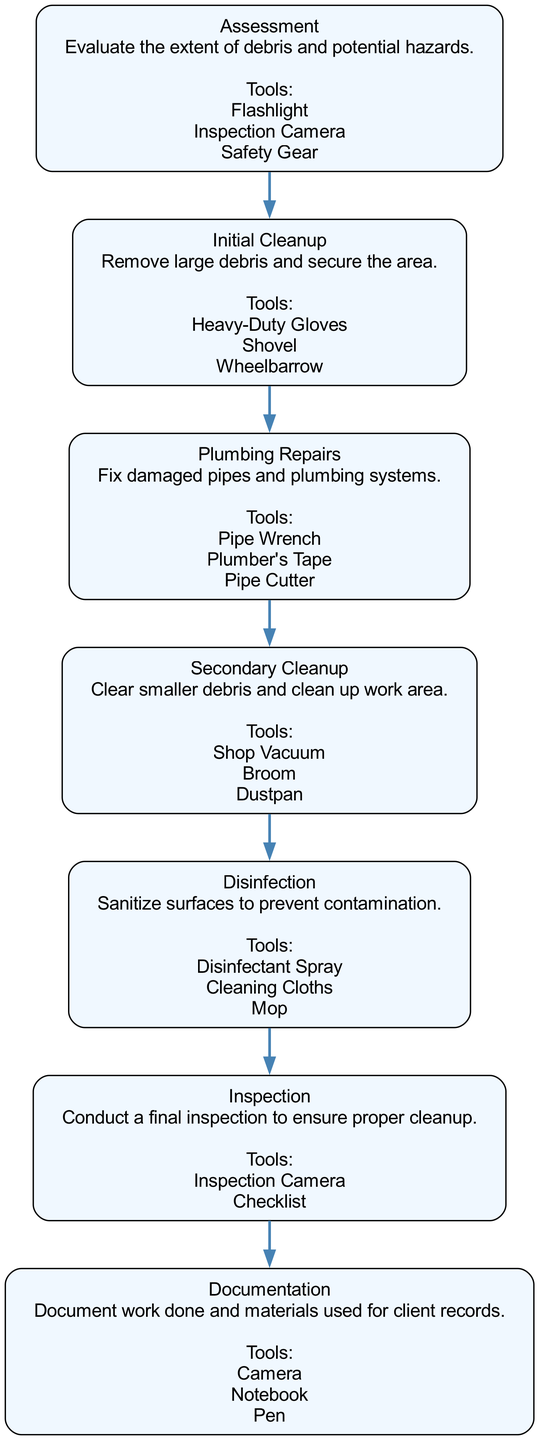What is the first step in the debris removal process? The diagram starts with the "Assessment" step, which is the initial stage of the process to evaluate the extent of debris and potential hazards.
Answer: Assessment How many tools are listed for the "Plumbing Repairs" step? In the "Plumbing Repairs" step, there are three tools mentioned: Pipe Wrench, Plumber's Tape, and Pipe Cutter.
Answer: 3 What step follows "Initial Cleanup"? The diagram shows that the step after "Initial Cleanup" is "Plumbing Repairs," indicating the progression from clearing larger debris to addressing plumbing issues.
Answer: Plumbing Repairs Which tool is used for the "Disinfection" step? The "Disinfection" step lists Disinfectant Spray, Cleaning Cloths, and Mop as tools, making them essential for sanitizing surfaces.
Answer: Disinfectant Spray What is the last step in the Clinical Pathway? The final step in the diagram is "Documentation," which denotes the importance of recording all work done and materials used for client records.
Answer: Documentation How is the "Secondary Cleanup" related to the previous step? "Secondary Cleanup" directly follows "Plumbing Repairs," showing that after plumbing issues are fixed, the next logical action is to clear smaller debris and clean up the work area.
Answer: Secondary Cleanup How many steps are there in total? The diagram includes seven distinct steps in the debris removal process, listed as individual nodes in the Clinical Pathway.
Answer: 7 What is the main purpose of the "Inspection" step? The purpose of the "Inspection" step is to conduct a final check to ensure that proper cleanup has been achieved, solidifying the thoroughness of the process.
Answer: Final inspection What tools are indicated for "Initial Cleanup"? The "Initial Cleanup" step indicates the use of Heavy-Duty Gloves, Shovel, and Wheelbarrow, which are crucial for managing large debris.
Answer: Heavy-Duty Gloves, Shovel, Wheelbarrow 